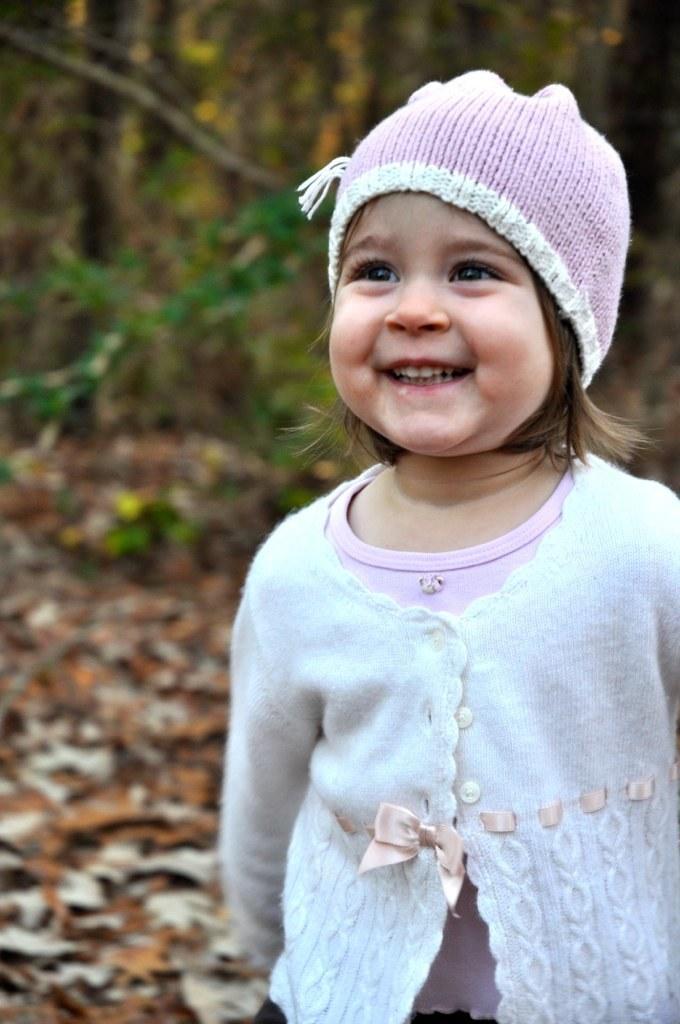Could you give a brief overview of what you see in this image? In this image there is a girl standing towards the right of the image, she is wearing a cap, there are dried leaves on the ground, at the background of the image there are trees. 